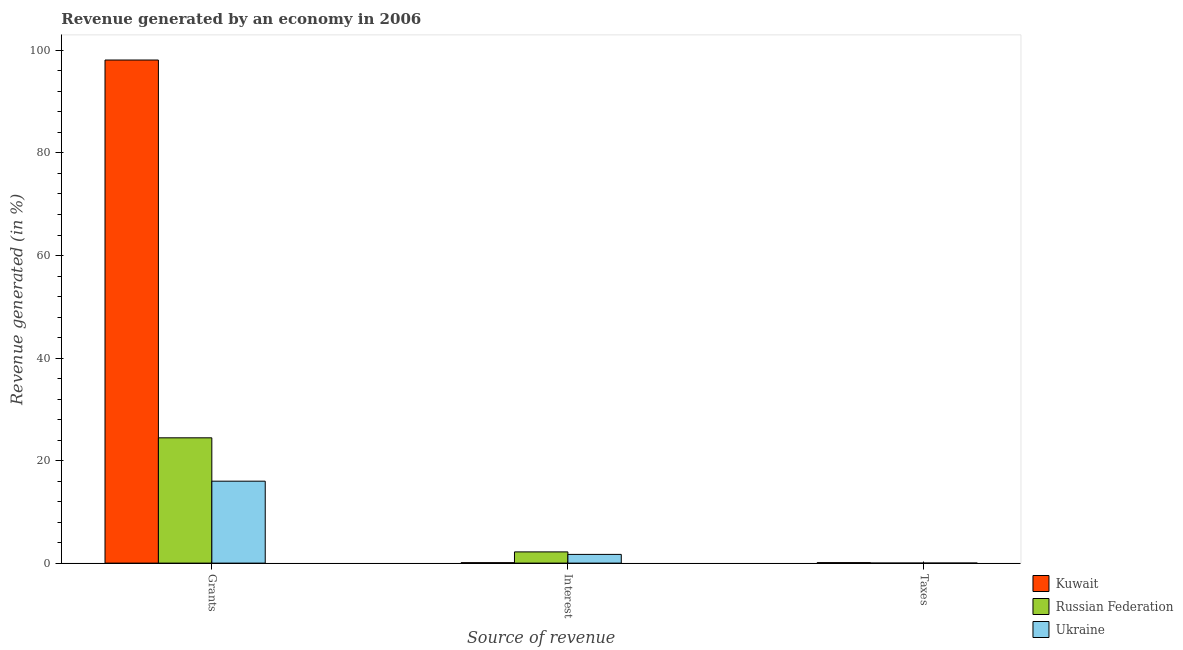How many groups of bars are there?
Provide a succinct answer. 3. Are the number of bars per tick equal to the number of legend labels?
Your response must be concise. Yes. Are the number of bars on each tick of the X-axis equal?
Your response must be concise. Yes. How many bars are there on the 3rd tick from the left?
Offer a very short reply. 3. How many bars are there on the 2nd tick from the right?
Give a very brief answer. 3. What is the label of the 1st group of bars from the left?
Your answer should be very brief. Grants. What is the percentage of revenue generated by taxes in Kuwait?
Provide a succinct answer. 0.09. Across all countries, what is the maximum percentage of revenue generated by taxes?
Your answer should be very brief. 0.09. Across all countries, what is the minimum percentage of revenue generated by grants?
Give a very brief answer. 15.98. In which country was the percentage of revenue generated by grants maximum?
Make the answer very short. Kuwait. In which country was the percentage of revenue generated by taxes minimum?
Provide a succinct answer. Russian Federation. What is the total percentage of revenue generated by taxes in the graph?
Your answer should be very brief. 0.1. What is the difference between the percentage of revenue generated by interest in Kuwait and that in Russian Federation?
Ensure brevity in your answer.  -2.1. What is the difference between the percentage of revenue generated by grants in Russian Federation and the percentage of revenue generated by interest in Ukraine?
Provide a short and direct response. 22.74. What is the average percentage of revenue generated by taxes per country?
Offer a very short reply. 0.03. What is the difference between the percentage of revenue generated by taxes and percentage of revenue generated by interest in Ukraine?
Give a very brief answer. -1.7. What is the ratio of the percentage of revenue generated by taxes in Kuwait to that in Russian Federation?
Make the answer very short. 24.11. Is the percentage of revenue generated by grants in Kuwait less than that in Ukraine?
Your response must be concise. No. Is the difference between the percentage of revenue generated by interest in Kuwait and Russian Federation greater than the difference between the percentage of revenue generated by grants in Kuwait and Russian Federation?
Ensure brevity in your answer.  No. What is the difference between the highest and the second highest percentage of revenue generated by taxes?
Your answer should be compact. 0.09. What is the difference between the highest and the lowest percentage of revenue generated by interest?
Keep it short and to the point. 2.1. What does the 2nd bar from the left in Grants represents?
Keep it short and to the point. Russian Federation. What does the 2nd bar from the right in Interest represents?
Provide a succinct answer. Russian Federation. Are all the bars in the graph horizontal?
Provide a short and direct response. No. How many countries are there in the graph?
Make the answer very short. 3. What is the difference between two consecutive major ticks on the Y-axis?
Your answer should be compact. 20. Are the values on the major ticks of Y-axis written in scientific E-notation?
Ensure brevity in your answer.  No. Does the graph contain any zero values?
Offer a terse response. No. Does the graph contain grids?
Provide a succinct answer. No. Where does the legend appear in the graph?
Keep it short and to the point. Bottom right. How many legend labels are there?
Ensure brevity in your answer.  3. How are the legend labels stacked?
Keep it short and to the point. Vertical. What is the title of the graph?
Ensure brevity in your answer.  Revenue generated by an economy in 2006. Does "Cameroon" appear as one of the legend labels in the graph?
Your answer should be very brief. No. What is the label or title of the X-axis?
Offer a terse response. Source of revenue. What is the label or title of the Y-axis?
Your answer should be compact. Revenue generated (in %). What is the Revenue generated (in %) in Kuwait in Grants?
Make the answer very short. 98.13. What is the Revenue generated (in %) of Russian Federation in Grants?
Your answer should be compact. 24.44. What is the Revenue generated (in %) in Ukraine in Grants?
Make the answer very short. 15.98. What is the Revenue generated (in %) of Kuwait in Interest?
Provide a short and direct response. 0.08. What is the Revenue generated (in %) in Russian Federation in Interest?
Offer a terse response. 2.19. What is the Revenue generated (in %) of Ukraine in Interest?
Make the answer very short. 1.7. What is the Revenue generated (in %) in Kuwait in Taxes?
Provide a short and direct response. 0.09. What is the Revenue generated (in %) in Russian Federation in Taxes?
Ensure brevity in your answer.  0. What is the Revenue generated (in %) of Ukraine in Taxes?
Offer a very short reply. 0. Across all Source of revenue, what is the maximum Revenue generated (in %) of Kuwait?
Provide a short and direct response. 98.13. Across all Source of revenue, what is the maximum Revenue generated (in %) of Russian Federation?
Offer a very short reply. 24.44. Across all Source of revenue, what is the maximum Revenue generated (in %) of Ukraine?
Provide a short and direct response. 15.98. Across all Source of revenue, what is the minimum Revenue generated (in %) of Kuwait?
Provide a short and direct response. 0.08. Across all Source of revenue, what is the minimum Revenue generated (in %) in Russian Federation?
Your answer should be compact. 0. Across all Source of revenue, what is the minimum Revenue generated (in %) of Ukraine?
Provide a short and direct response. 0. What is the total Revenue generated (in %) of Kuwait in the graph?
Make the answer very short. 98.31. What is the total Revenue generated (in %) in Russian Federation in the graph?
Offer a very short reply. 26.63. What is the total Revenue generated (in %) of Ukraine in the graph?
Give a very brief answer. 17.68. What is the difference between the Revenue generated (in %) in Kuwait in Grants and that in Interest?
Your response must be concise. 98.05. What is the difference between the Revenue generated (in %) in Russian Federation in Grants and that in Interest?
Your response must be concise. 22.25. What is the difference between the Revenue generated (in %) in Ukraine in Grants and that in Interest?
Make the answer very short. 14.28. What is the difference between the Revenue generated (in %) of Kuwait in Grants and that in Taxes?
Make the answer very short. 98.04. What is the difference between the Revenue generated (in %) of Russian Federation in Grants and that in Taxes?
Your answer should be very brief. 24.44. What is the difference between the Revenue generated (in %) in Ukraine in Grants and that in Taxes?
Provide a short and direct response. 15.98. What is the difference between the Revenue generated (in %) in Kuwait in Interest and that in Taxes?
Keep it short and to the point. -0.01. What is the difference between the Revenue generated (in %) of Russian Federation in Interest and that in Taxes?
Give a very brief answer. 2.18. What is the difference between the Revenue generated (in %) of Ukraine in Interest and that in Taxes?
Your answer should be compact. 1.7. What is the difference between the Revenue generated (in %) in Kuwait in Grants and the Revenue generated (in %) in Russian Federation in Interest?
Your response must be concise. 95.94. What is the difference between the Revenue generated (in %) in Kuwait in Grants and the Revenue generated (in %) in Ukraine in Interest?
Keep it short and to the point. 96.43. What is the difference between the Revenue generated (in %) of Russian Federation in Grants and the Revenue generated (in %) of Ukraine in Interest?
Provide a short and direct response. 22.74. What is the difference between the Revenue generated (in %) of Kuwait in Grants and the Revenue generated (in %) of Russian Federation in Taxes?
Provide a short and direct response. 98.13. What is the difference between the Revenue generated (in %) of Kuwait in Grants and the Revenue generated (in %) of Ukraine in Taxes?
Give a very brief answer. 98.13. What is the difference between the Revenue generated (in %) in Russian Federation in Grants and the Revenue generated (in %) in Ukraine in Taxes?
Offer a terse response. 24.44. What is the difference between the Revenue generated (in %) of Kuwait in Interest and the Revenue generated (in %) of Russian Federation in Taxes?
Your answer should be very brief. 0.08. What is the difference between the Revenue generated (in %) in Kuwait in Interest and the Revenue generated (in %) in Ukraine in Taxes?
Offer a terse response. 0.08. What is the difference between the Revenue generated (in %) of Russian Federation in Interest and the Revenue generated (in %) of Ukraine in Taxes?
Provide a short and direct response. 2.18. What is the average Revenue generated (in %) of Kuwait per Source of revenue?
Make the answer very short. 32.77. What is the average Revenue generated (in %) in Russian Federation per Source of revenue?
Provide a short and direct response. 8.88. What is the average Revenue generated (in %) in Ukraine per Source of revenue?
Keep it short and to the point. 5.89. What is the difference between the Revenue generated (in %) of Kuwait and Revenue generated (in %) of Russian Federation in Grants?
Your answer should be very brief. 73.69. What is the difference between the Revenue generated (in %) of Kuwait and Revenue generated (in %) of Ukraine in Grants?
Your answer should be very brief. 82.15. What is the difference between the Revenue generated (in %) in Russian Federation and Revenue generated (in %) in Ukraine in Grants?
Your answer should be compact. 8.46. What is the difference between the Revenue generated (in %) in Kuwait and Revenue generated (in %) in Russian Federation in Interest?
Offer a very short reply. -2.1. What is the difference between the Revenue generated (in %) in Kuwait and Revenue generated (in %) in Ukraine in Interest?
Offer a terse response. -1.61. What is the difference between the Revenue generated (in %) of Russian Federation and Revenue generated (in %) of Ukraine in Interest?
Provide a succinct answer. 0.49. What is the difference between the Revenue generated (in %) in Kuwait and Revenue generated (in %) in Russian Federation in Taxes?
Offer a very short reply. 0.09. What is the difference between the Revenue generated (in %) of Kuwait and Revenue generated (in %) of Ukraine in Taxes?
Offer a very short reply. 0.09. What is the difference between the Revenue generated (in %) in Russian Federation and Revenue generated (in %) in Ukraine in Taxes?
Your answer should be very brief. -0. What is the ratio of the Revenue generated (in %) in Kuwait in Grants to that in Interest?
Your response must be concise. 1155.23. What is the ratio of the Revenue generated (in %) of Russian Federation in Grants to that in Interest?
Ensure brevity in your answer.  11.17. What is the ratio of the Revenue generated (in %) of Ukraine in Grants to that in Interest?
Provide a succinct answer. 9.4. What is the ratio of the Revenue generated (in %) in Kuwait in Grants to that in Taxes?
Provide a succinct answer. 1072.71. What is the ratio of the Revenue generated (in %) of Russian Federation in Grants to that in Taxes?
Offer a very short reply. 6440.33. What is the ratio of the Revenue generated (in %) of Ukraine in Grants to that in Taxes?
Provide a short and direct response. 3781.18. What is the ratio of the Revenue generated (in %) of Russian Federation in Interest to that in Taxes?
Ensure brevity in your answer.  576.33. What is the ratio of the Revenue generated (in %) in Ukraine in Interest to that in Taxes?
Ensure brevity in your answer.  402.05. What is the difference between the highest and the second highest Revenue generated (in %) of Kuwait?
Offer a terse response. 98.04. What is the difference between the highest and the second highest Revenue generated (in %) in Russian Federation?
Your answer should be compact. 22.25. What is the difference between the highest and the second highest Revenue generated (in %) of Ukraine?
Give a very brief answer. 14.28. What is the difference between the highest and the lowest Revenue generated (in %) in Kuwait?
Offer a terse response. 98.05. What is the difference between the highest and the lowest Revenue generated (in %) in Russian Federation?
Give a very brief answer. 24.44. What is the difference between the highest and the lowest Revenue generated (in %) of Ukraine?
Your answer should be compact. 15.98. 